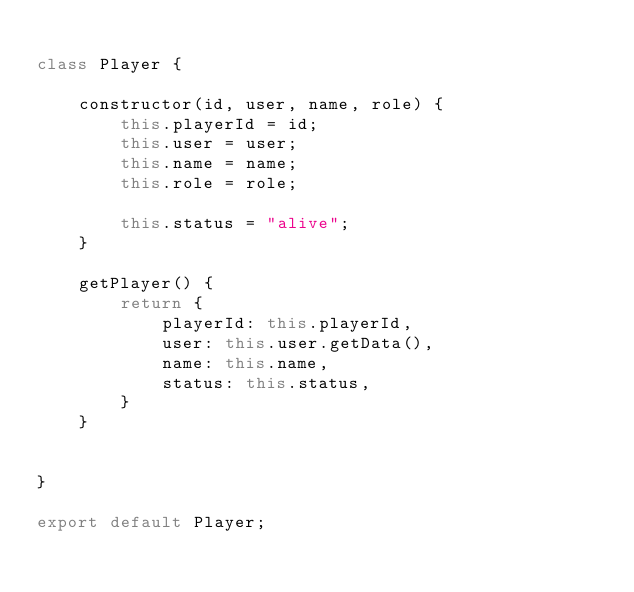Convert code to text. <code><loc_0><loc_0><loc_500><loc_500><_JavaScript_>
class Player {

    constructor(id, user, name, role) {
        this.playerId = id;
        this.user = user;
        this.name = name;
        this.role = role;

        this.status = "alive";
    }

    getPlayer() {
        return {
            playerId: this.playerId,
            user: this.user.getData(),
            name: this.name,
            status: this.status,
        }
    }


}

export default Player;</code> 